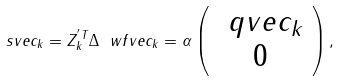<formula> <loc_0><loc_0><loc_500><loc_500>\ s v e c _ { k } = Z _ { k } ^ { ^ { \prime } T } \Delta \ w f v e c _ { k } = \alpha \left ( \begin{array} { c } \ q v e c _ { k } \\ 0 \\ \end{array} \right ) ,</formula> 